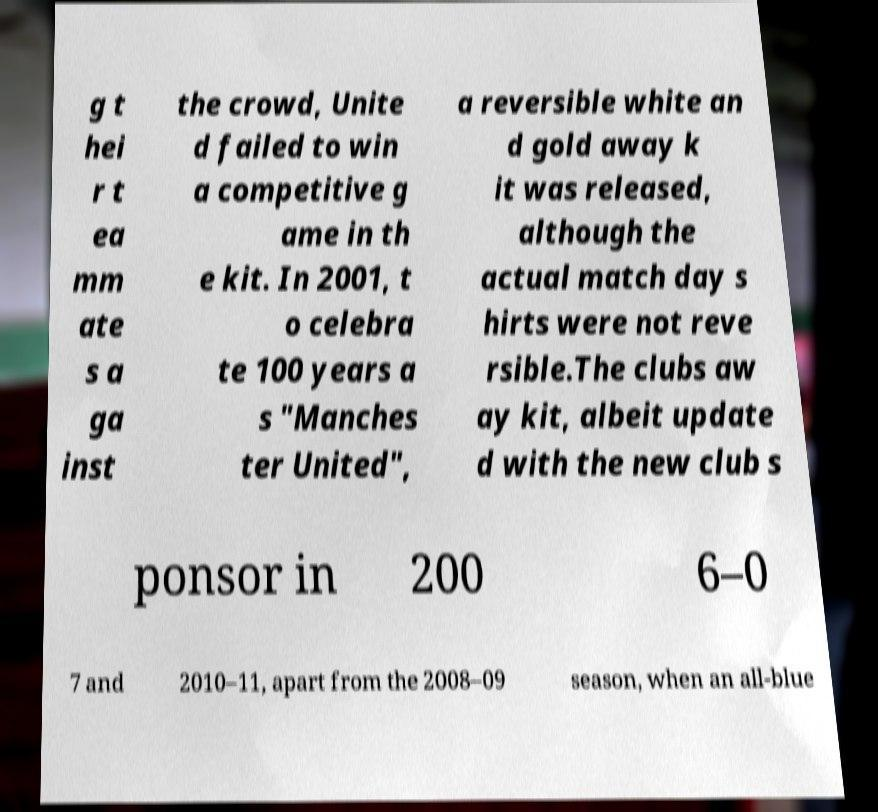Please read and relay the text visible in this image. What does it say? g t hei r t ea mm ate s a ga inst the crowd, Unite d failed to win a competitive g ame in th e kit. In 2001, t o celebra te 100 years a s "Manches ter United", a reversible white an d gold away k it was released, although the actual match day s hirts were not reve rsible.The clubs aw ay kit, albeit update d with the new club s ponsor in 200 6–0 7 and 2010–11, apart from the 2008–09 season, when an all-blue 